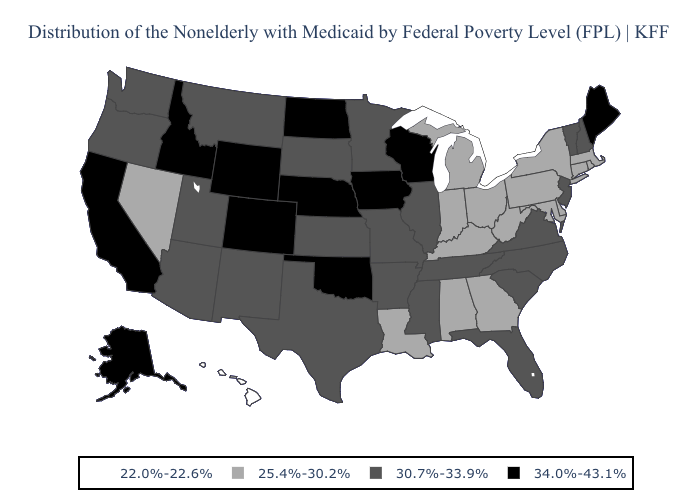What is the value of North Dakota?
Keep it brief. 34.0%-43.1%. What is the value of Minnesota?
Answer briefly. 30.7%-33.9%. What is the value of California?
Write a very short answer. 34.0%-43.1%. What is the value of Texas?
Short answer required. 30.7%-33.9%. What is the highest value in states that border Washington?
Concise answer only. 34.0%-43.1%. Name the states that have a value in the range 34.0%-43.1%?
Write a very short answer. Alaska, California, Colorado, Idaho, Iowa, Maine, Nebraska, North Dakota, Oklahoma, Wisconsin, Wyoming. What is the highest value in the USA?
Answer briefly. 34.0%-43.1%. Name the states that have a value in the range 22.0%-22.6%?
Concise answer only. Hawaii. What is the value of South Carolina?
Answer briefly. 30.7%-33.9%. Name the states that have a value in the range 25.4%-30.2%?
Quick response, please. Alabama, Connecticut, Delaware, Georgia, Indiana, Kentucky, Louisiana, Maryland, Massachusetts, Michigan, Nevada, New York, Ohio, Pennsylvania, Rhode Island, West Virginia. What is the value of Idaho?
Short answer required. 34.0%-43.1%. Name the states that have a value in the range 22.0%-22.6%?
Write a very short answer. Hawaii. Does Rhode Island have a lower value than Massachusetts?
Short answer required. No. Among the states that border Minnesota , does South Dakota have the lowest value?
Be succinct. Yes. Does Oklahoma have the same value as Oregon?
Answer briefly. No. 